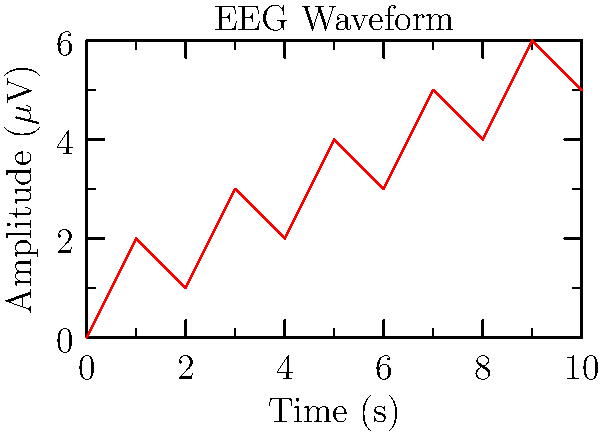Analyze the given EEG waveform. What is the approximate frequency band this signal belongs to, and what cognitive state might it represent? To determine the frequency band and cognitive state, we need to follow these steps:

1. Calculate the frequency of the waveform:
   - Count the number of complete cycles in the graph: approximately 5 cycles
   - Time period shown: 10 seconds
   - Frequency = Number of cycles / Time period
   - Frequency ≈ 5 / 10 = 0.5 Hz

2. Compare the calculated frequency to known EEG frequency bands:
   - Delta: 0.5 - 4 Hz
   - Theta: 4 - 8 Hz
   - Alpha: 8 - 13 Hz
   - Beta: 13 - 30 Hz
   - Gamma: > 30 Hz

3. The calculated frequency (0.5 Hz) falls within the Delta band.

4. Delta waves are associated with:
   - Deep sleep
   - Unconsciousness
   - Some brain disorders

Given the context of neurosurgery in biomedical engineering, this waveform likely represents a patient in a deep sleep state or under general anesthesia during a surgical procedure.
Answer: Delta band (0.5 - 4 Hz); deep sleep or anesthesia 